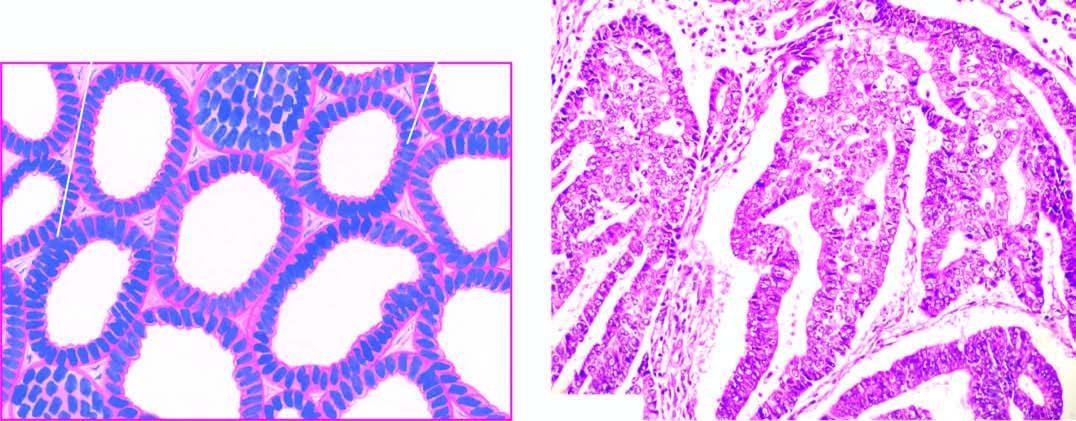what is the most common histologic pattern?
Answer the question using a single word or phrase. Well-differentiated adenocarcinoma showing closely packed glands with cytologic atypia 